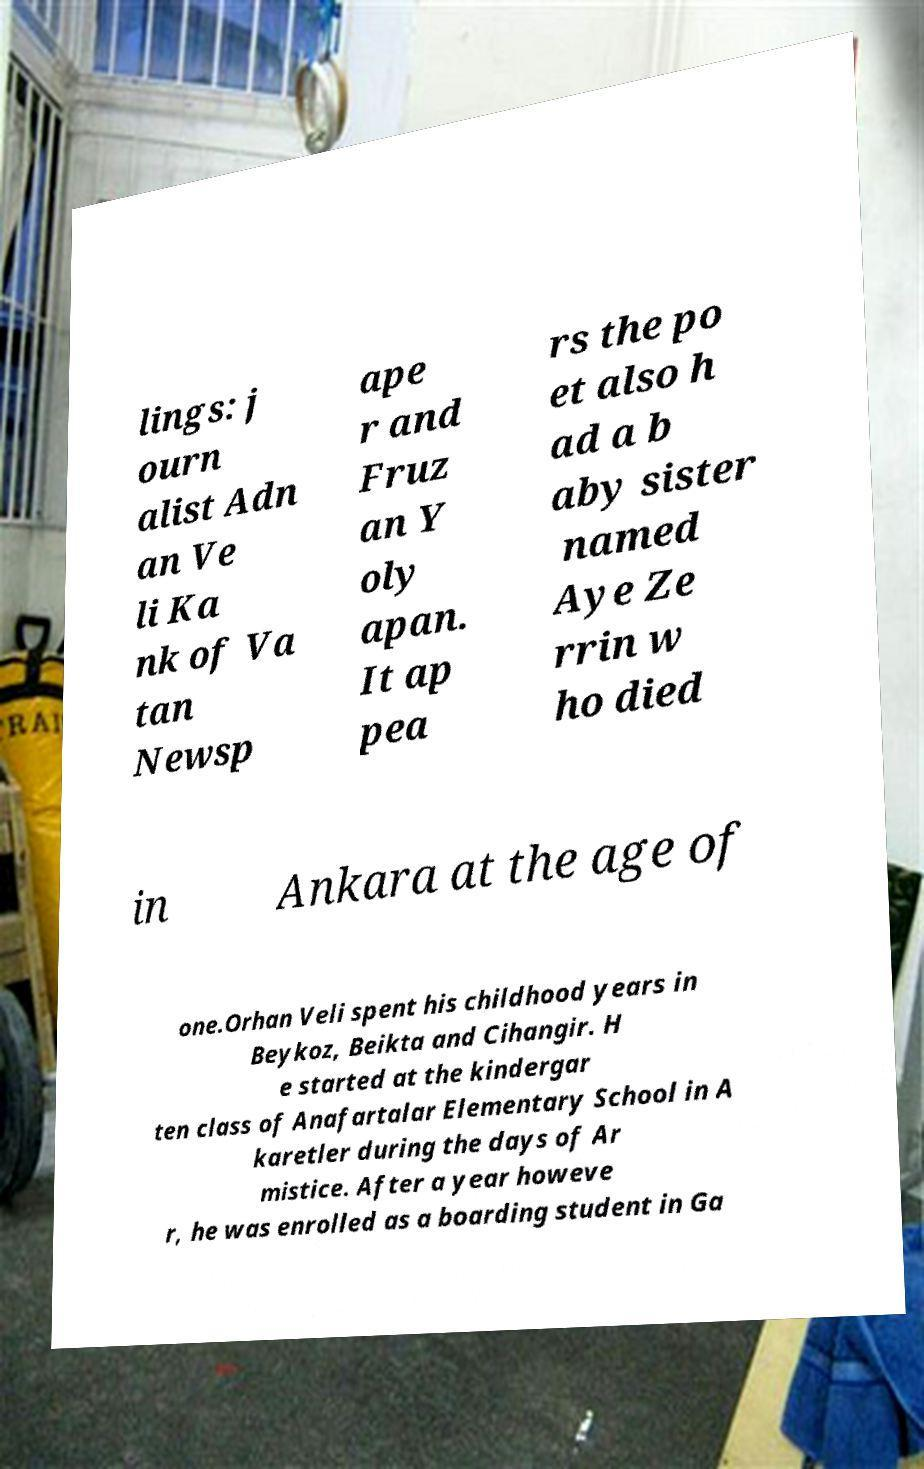Please identify and transcribe the text found in this image. lings: j ourn alist Adn an Ve li Ka nk of Va tan Newsp ape r and Fruz an Y oly apan. It ap pea rs the po et also h ad a b aby sister named Aye Ze rrin w ho died in Ankara at the age of one.Orhan Veli spent his childhood years in Beykoz, Beikta and Cihangir. H e started at the kindergar ten class of Anafartalar Elementary School in A karetler during the days of Ar mistice. After a year howeve r, he was enrolled as a boarding student in Ga 